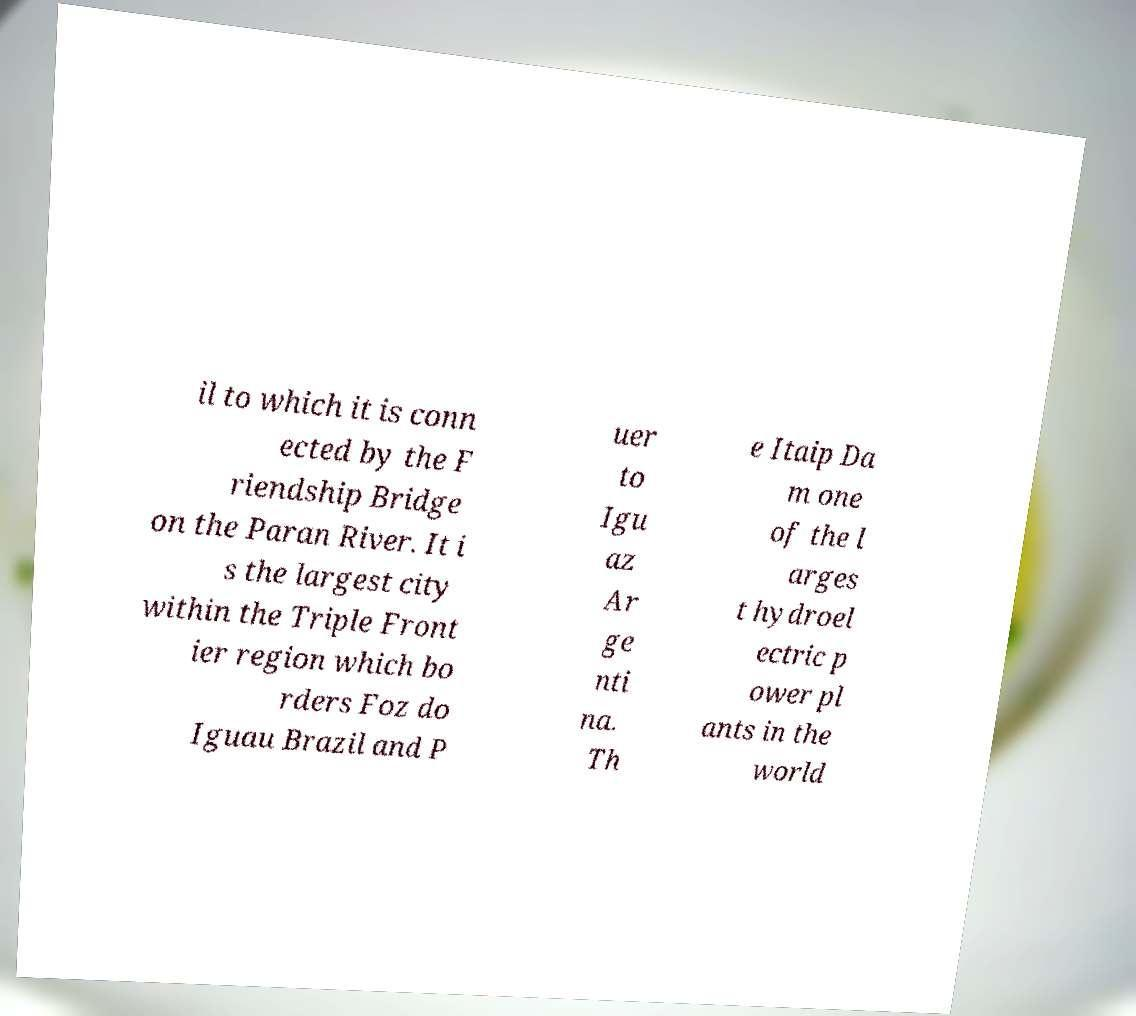Can you accurately transcribe the text from the provided image for me? il to which it is conn ected by the F riendship Bridge on the Paran River. It i s the largest city within the Triple Front ier region which bo rders Foz do Iguau Brazil and P uer to Igu az Ar ge nti na. Th e Itaip Da m one of the l arges t hydroel ectric p ower pl ants in the world 